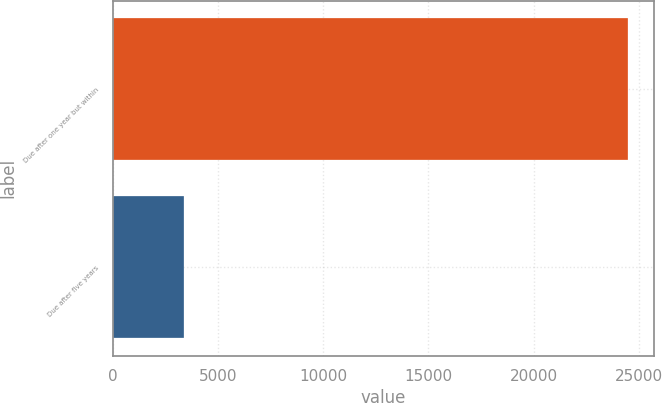Convert chart to OTSL. <chart><loc_0><loc_0><loc_500><loc_500><bar_chart><fcel>Due after one year but within<fcel>Due after five years<nl><fcel>24486<fcel>3354<nl></chart> 